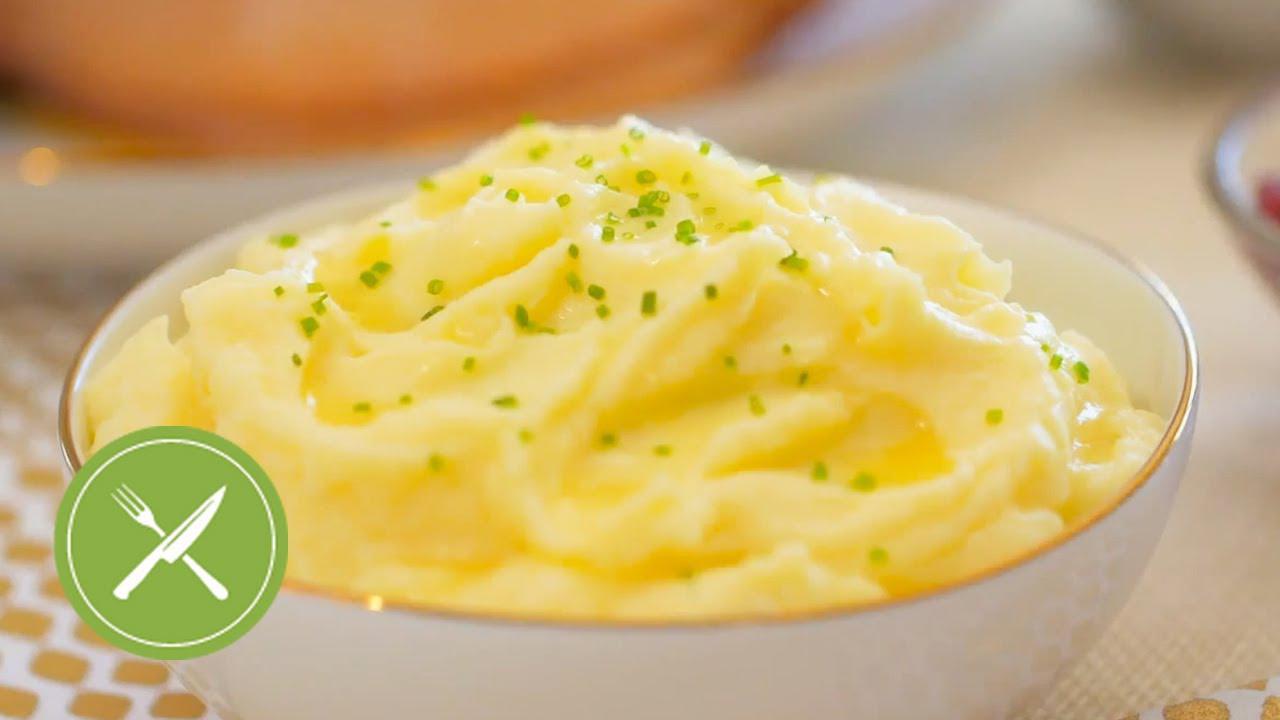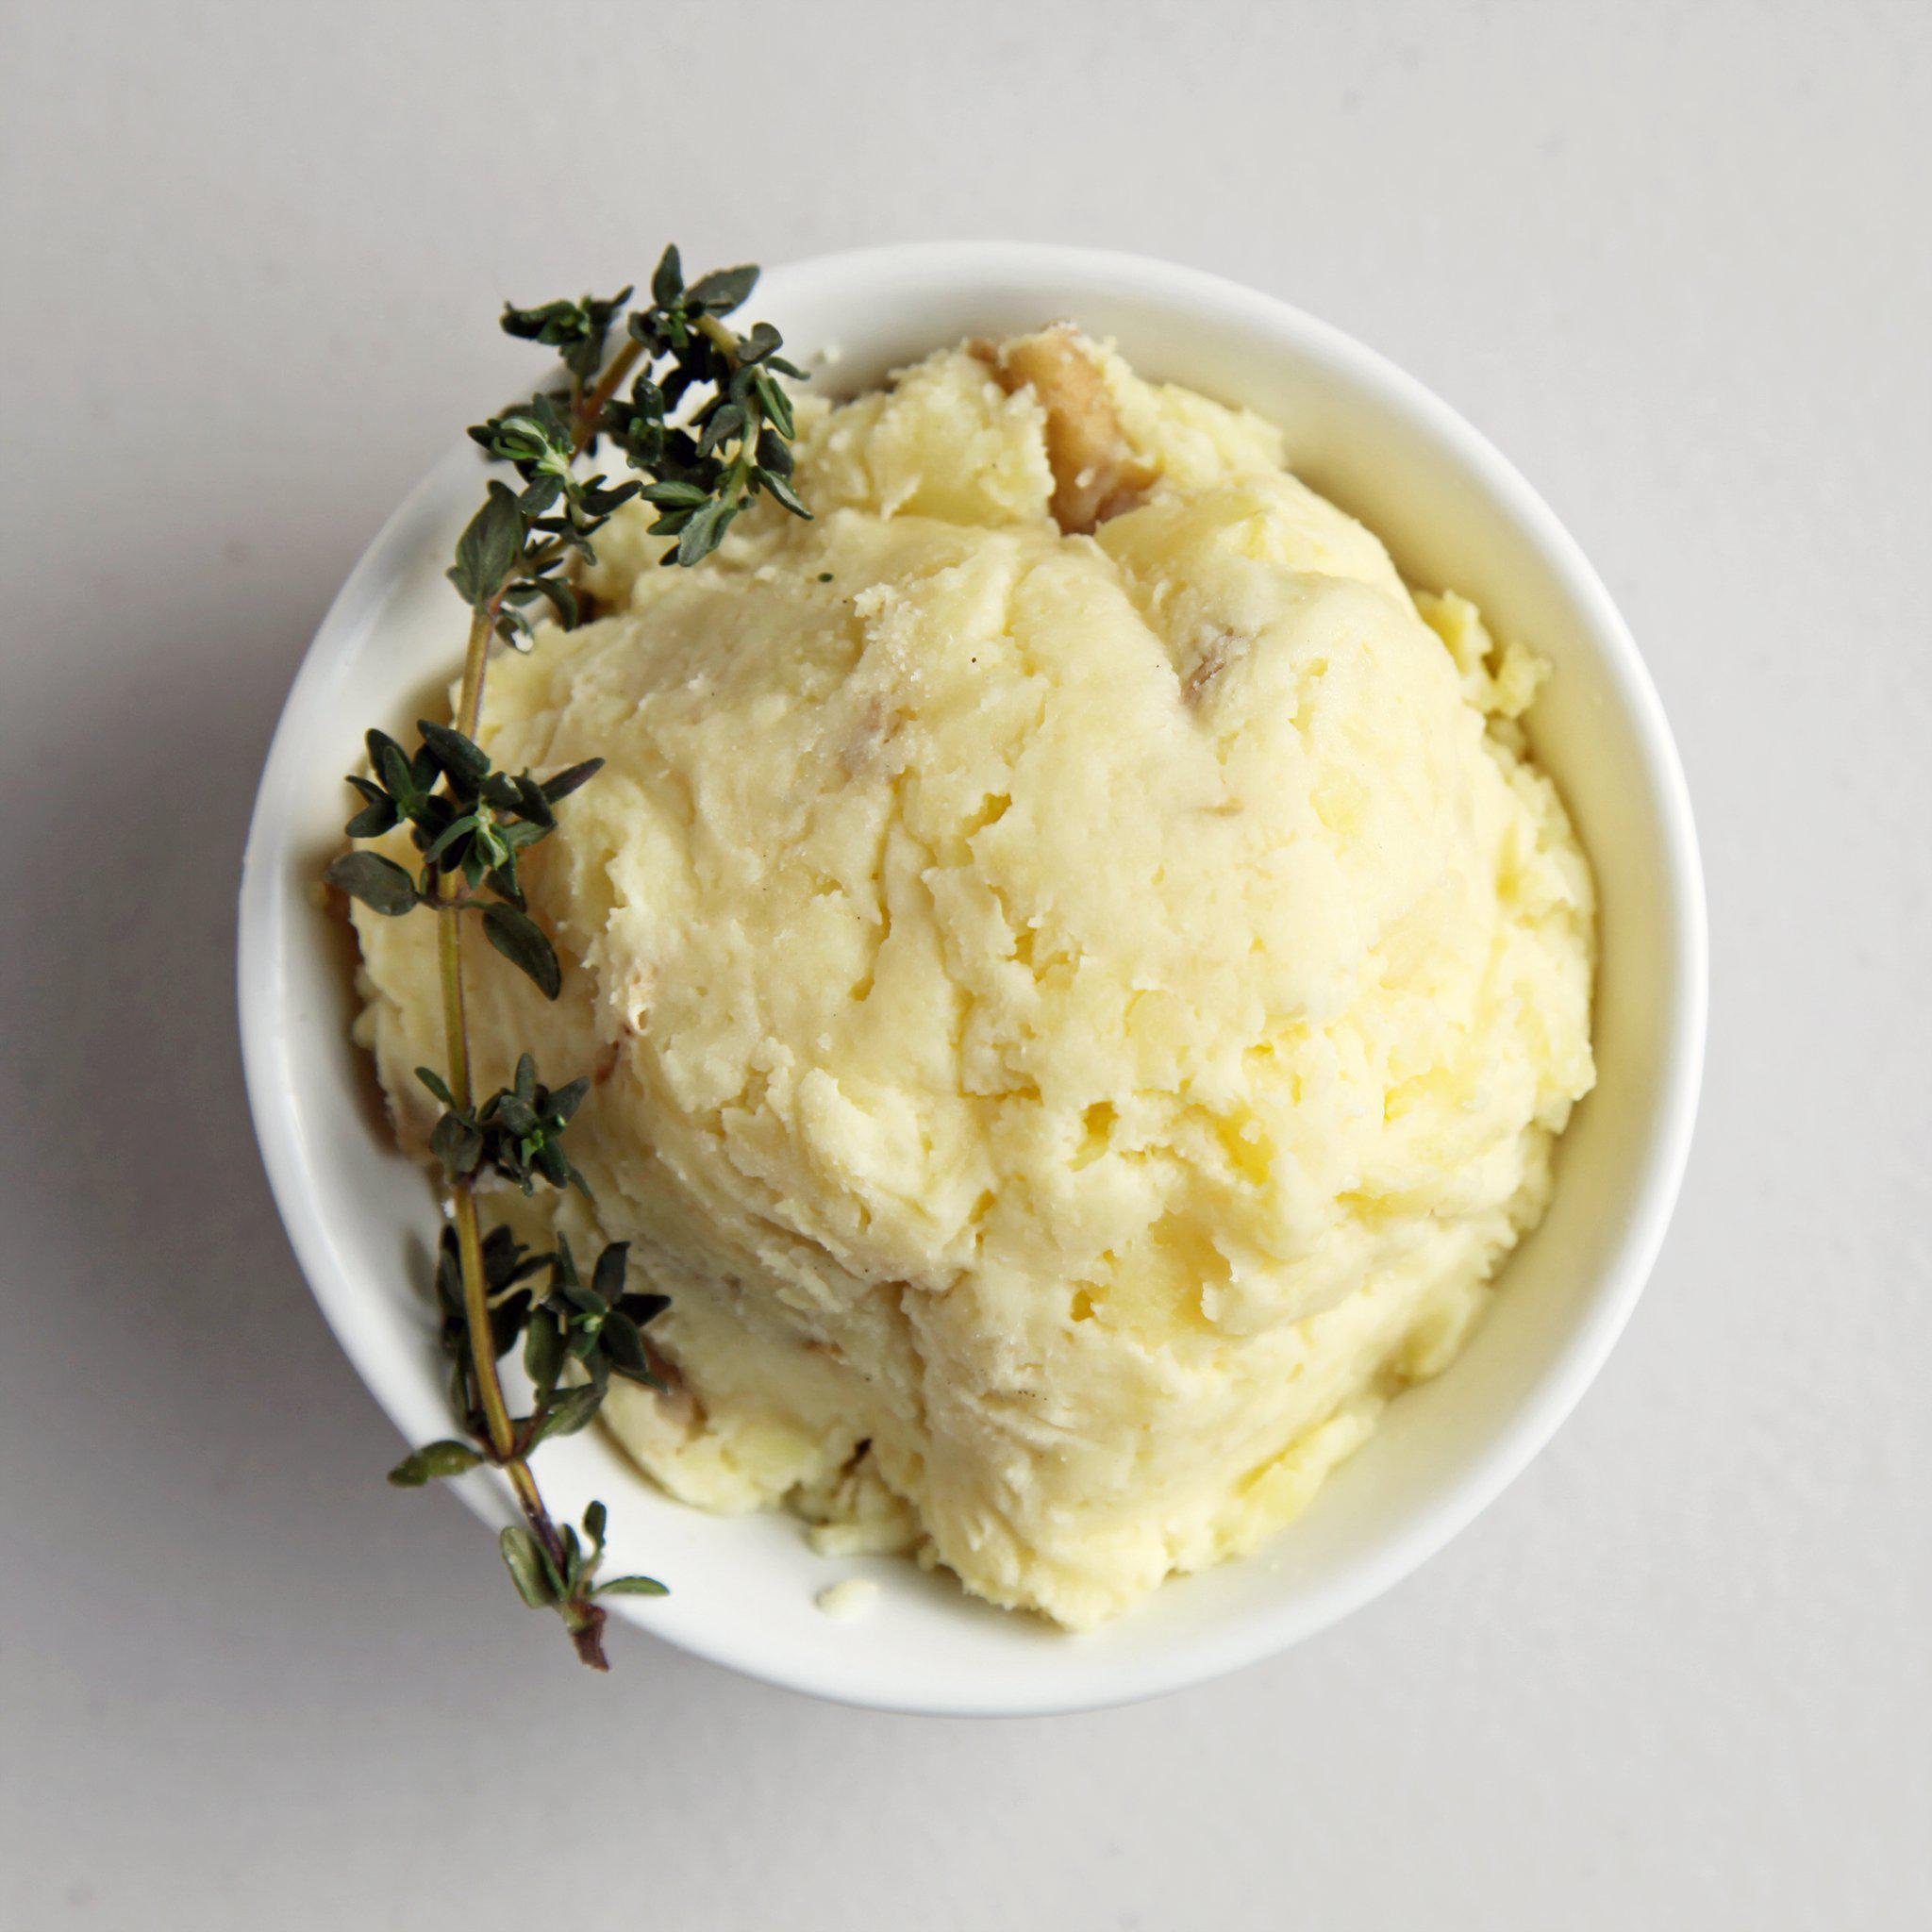The first image is the image on the left, the second image is the image on the right. Assess this claim about the two images: "One image features a bowl of potatoes with a spoon in the food.". Correct or not? Answer yes or no. No. The first image is the image on the left, the second image is the image on the right. Analyze the images presented: Is the assertion "A spoon sits in a bowl of potatoes in one of the images." valid? Answer yes or no. No. 